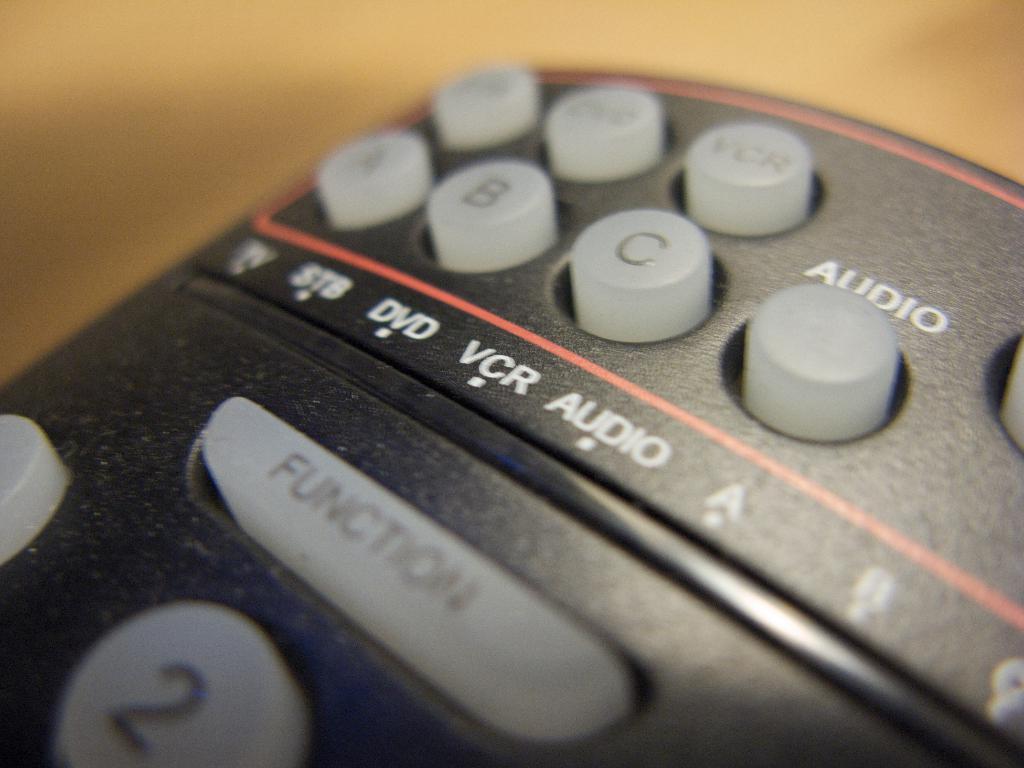The largest button is labeled what?
Offer a terse response. Function. What button is above the c button?
Offer a very short reply. Vcr. 